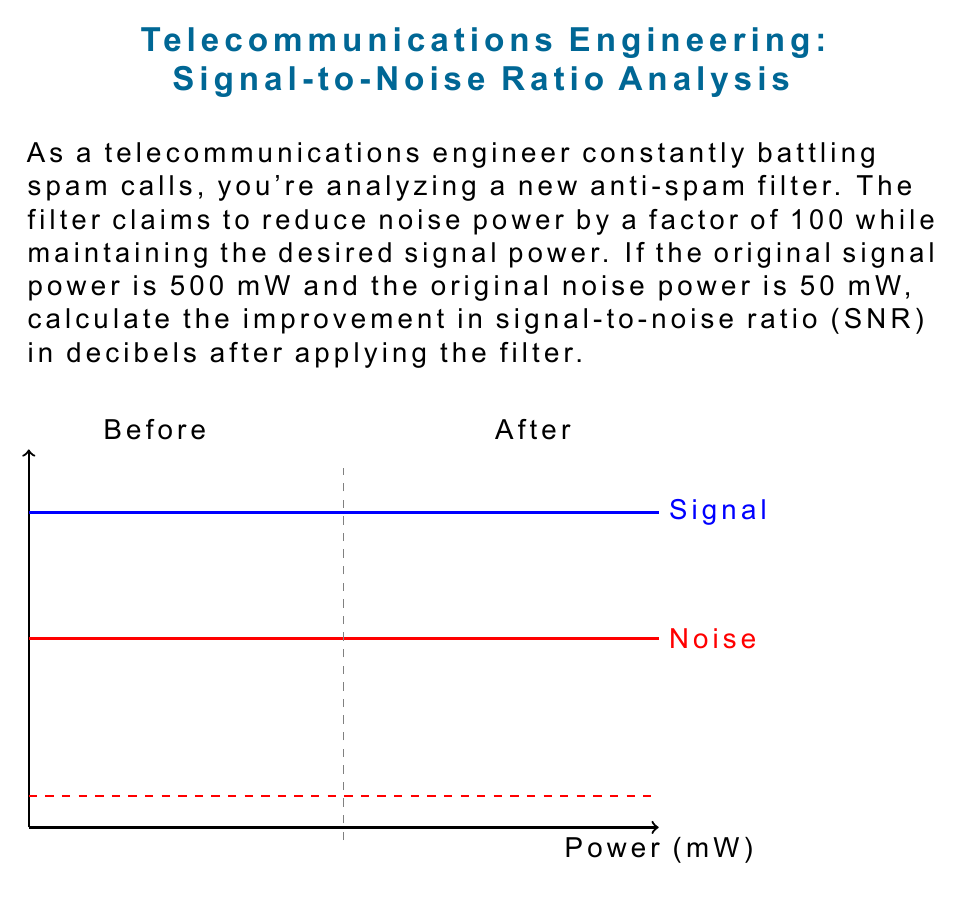Provide a solution to this math problem. Let's approach this step-by-step:

1) First, we need to calculate the original SNR:
   $$ \text{SNR}_{\text{original}} = \frac{P_{\text{signal}}}{P_{\text{noise}}} = \frac{500 \text{ mW}}{50 \text{ mW}} = 10 $$

2) After applying the filter, the signal power remains the same, but the noise power is reduced by a factor of 100:
   $$ P_{\text{signal,new}} = 500 \text{ mW} $$
   $$ P_{\text{noise,new}} = \frac{50 \text{ mW}}{100} = 0.5 \text{ mW} $$

3) Calculate the new SNR:
   $$ \text{SNR}_{\text{new}} = \frac{P_{\text{signal,new}}}{P_{\text{noise,new}}} = \frac{500 \text{ mW}}{0.5 \text{ mW}} = 1000 $$

4) To find the improvement, we need to calculate the ratio of the new SNR to the original SNR:
   $$ \text{Improvement} = \frac{\text{SNR}_{\text{new}}}{\text{SNR}_{\text{original}}} = \frac{1000}{10} = 100 $$

5) Finally, we convert this improvement to decibels using the formula:
   $$ \text{Improvement (dB)} = 10 \log_{10}(\text{Improvement}) $$
   $$ = 10 \log_{10}(100) = 10 \cdot 2 = 20 \text{ dB} $$

Thus, the improvement in SNR after applying the filter is 20 dB.
Answer: 20 dB 